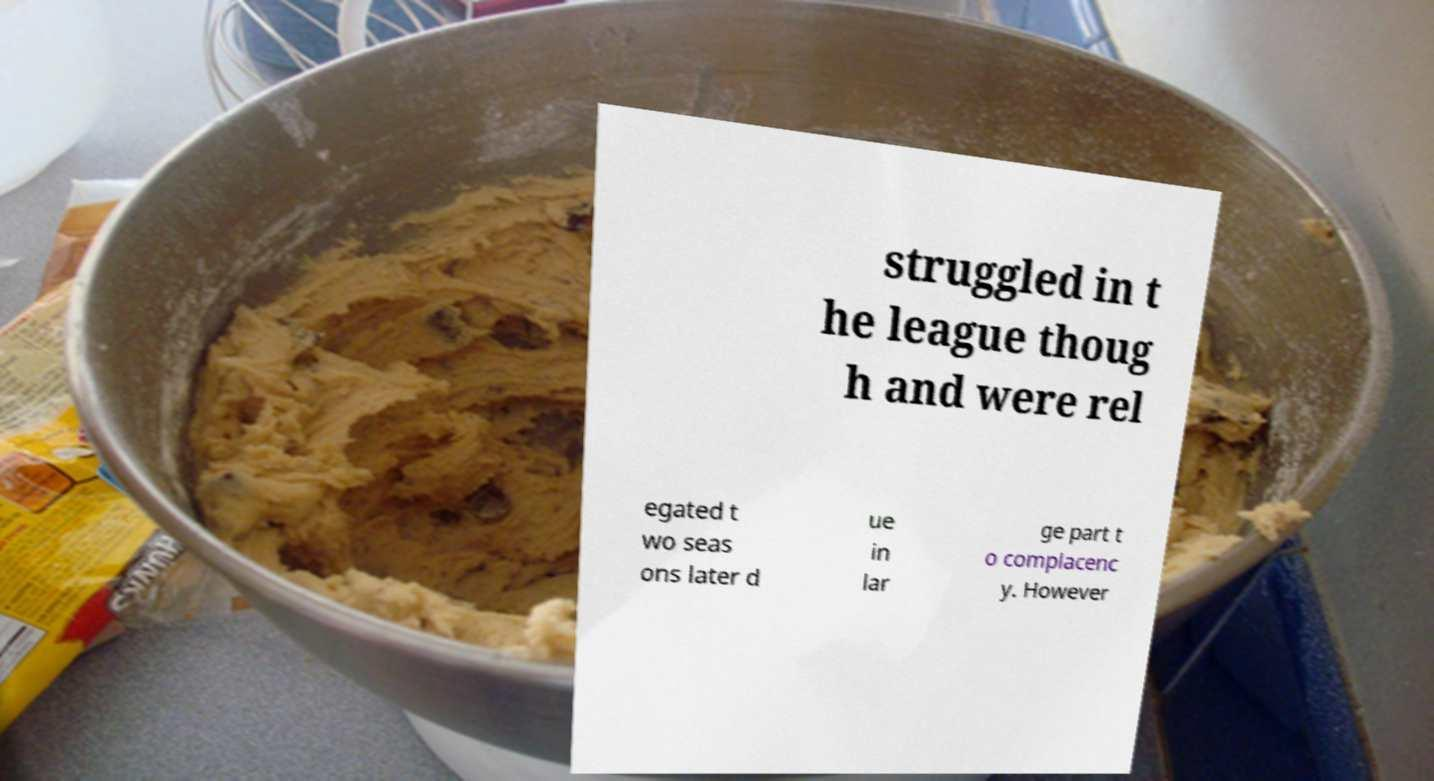What messages or text are displayed in this image? I need them in a readable, typed format. struggled in t he league thoug h and were rel egated t wo seas ons later d ue in lar ge part t o complacenc y. However 